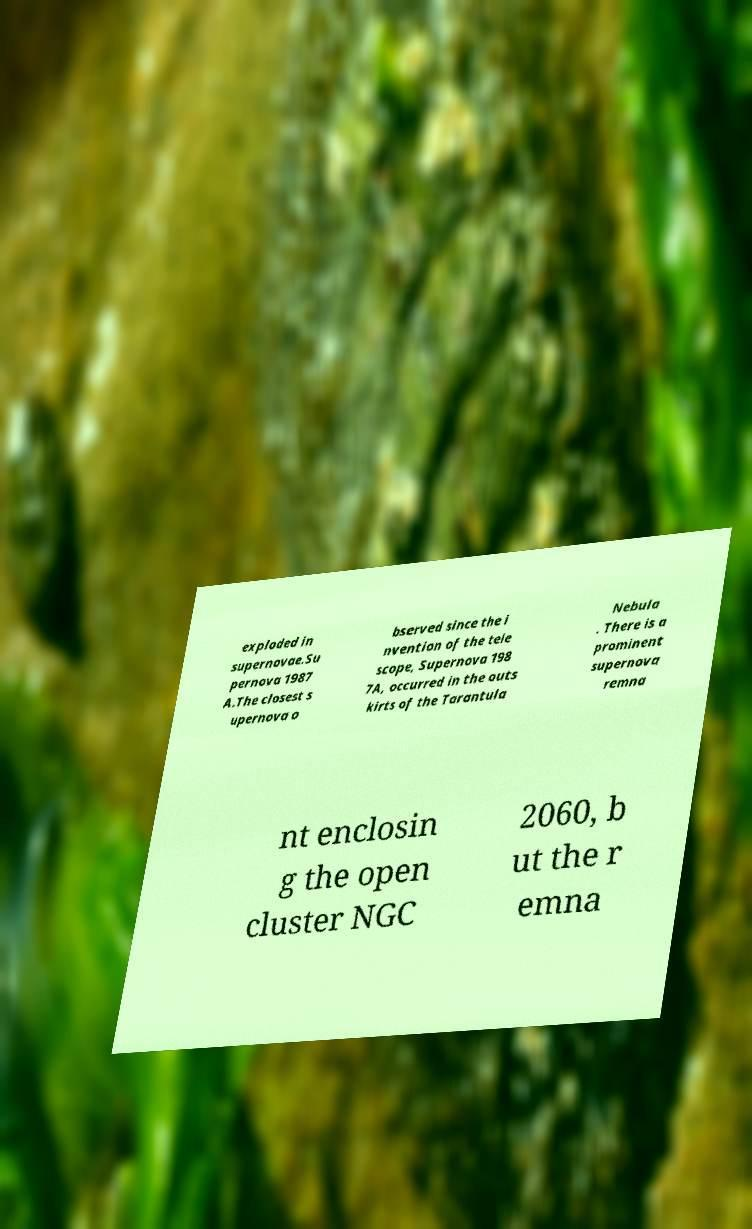For documentation purposes, I need the text within this image transcribed. Could you provide that? exploded in supernovae.Su pernova 1987 A.The closest s upernova o bserved since the i nvention of the tele scope, Supernova 198 7A, occurred in the outs kirts of the Tarantula Nebula . There is a prominent supernova remna nt enclosin g the open cluster NGC 2060, b ut the r emna 